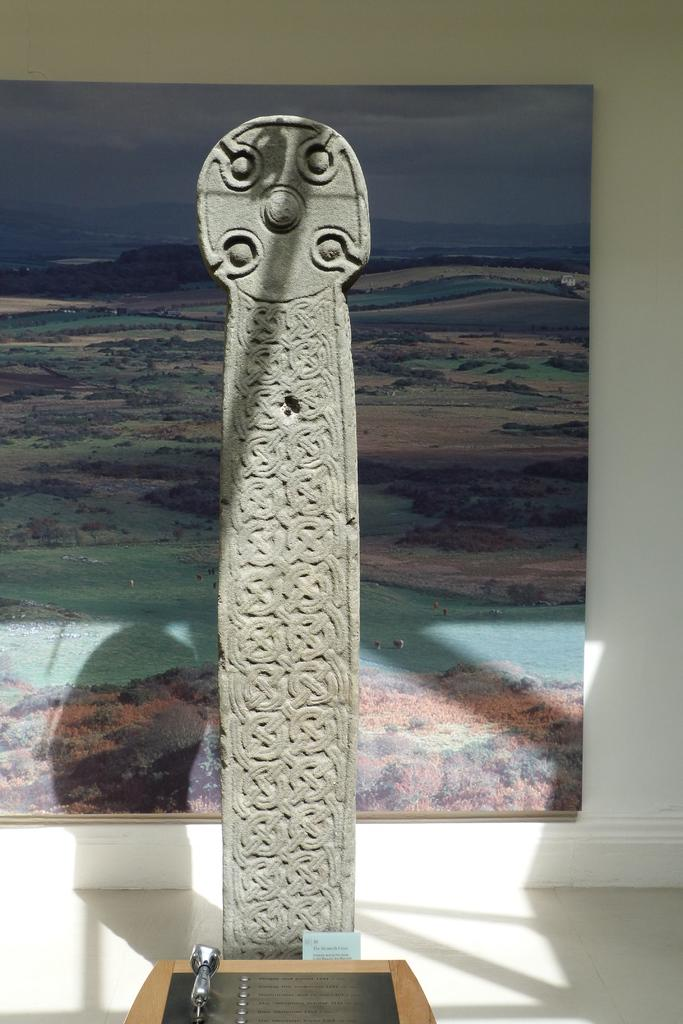What type of structure can be seen in the image? There is a structure made of cement in the image. What else can be seen in the background of the image? There is a wall frame, hills, water, and the sky visible in the background of the image. What type of honey can be seen dripping from the wall frame in the image? There is no honey present in the image; it features a cement structure, wall frame, hills, water, and sky. 